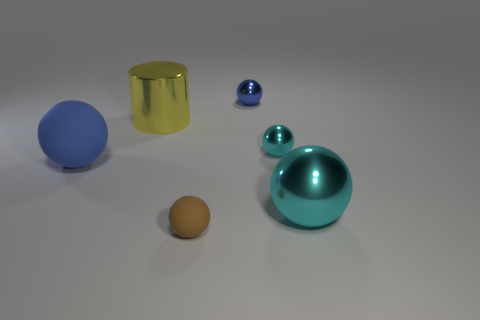Add 1 big matte objects. How many objects exist? 7 Subtract all small cyan shiny balls. How many balls are left? 4 Subtract 5 spheres. How many spheres are left? 0 Subtract all brown spheres. How many spheres are left? 4 Subtract all red cylinders. Subtract all gray balls. How many cylinders are left? 1 Subtract all red blocks. How many brown spheres are left? 1 Subtract all large green metal cylinders. Subtract all rubber things. How many objects are left? 4 Add 3 large yellow cylinders. How many large yellow cylinders are left? 4 Add 4 tiny blue shiny spheres. How many tiny blue shiny spheres exist? 5 Subtract 0 purple balls. How many objects are left? 6 